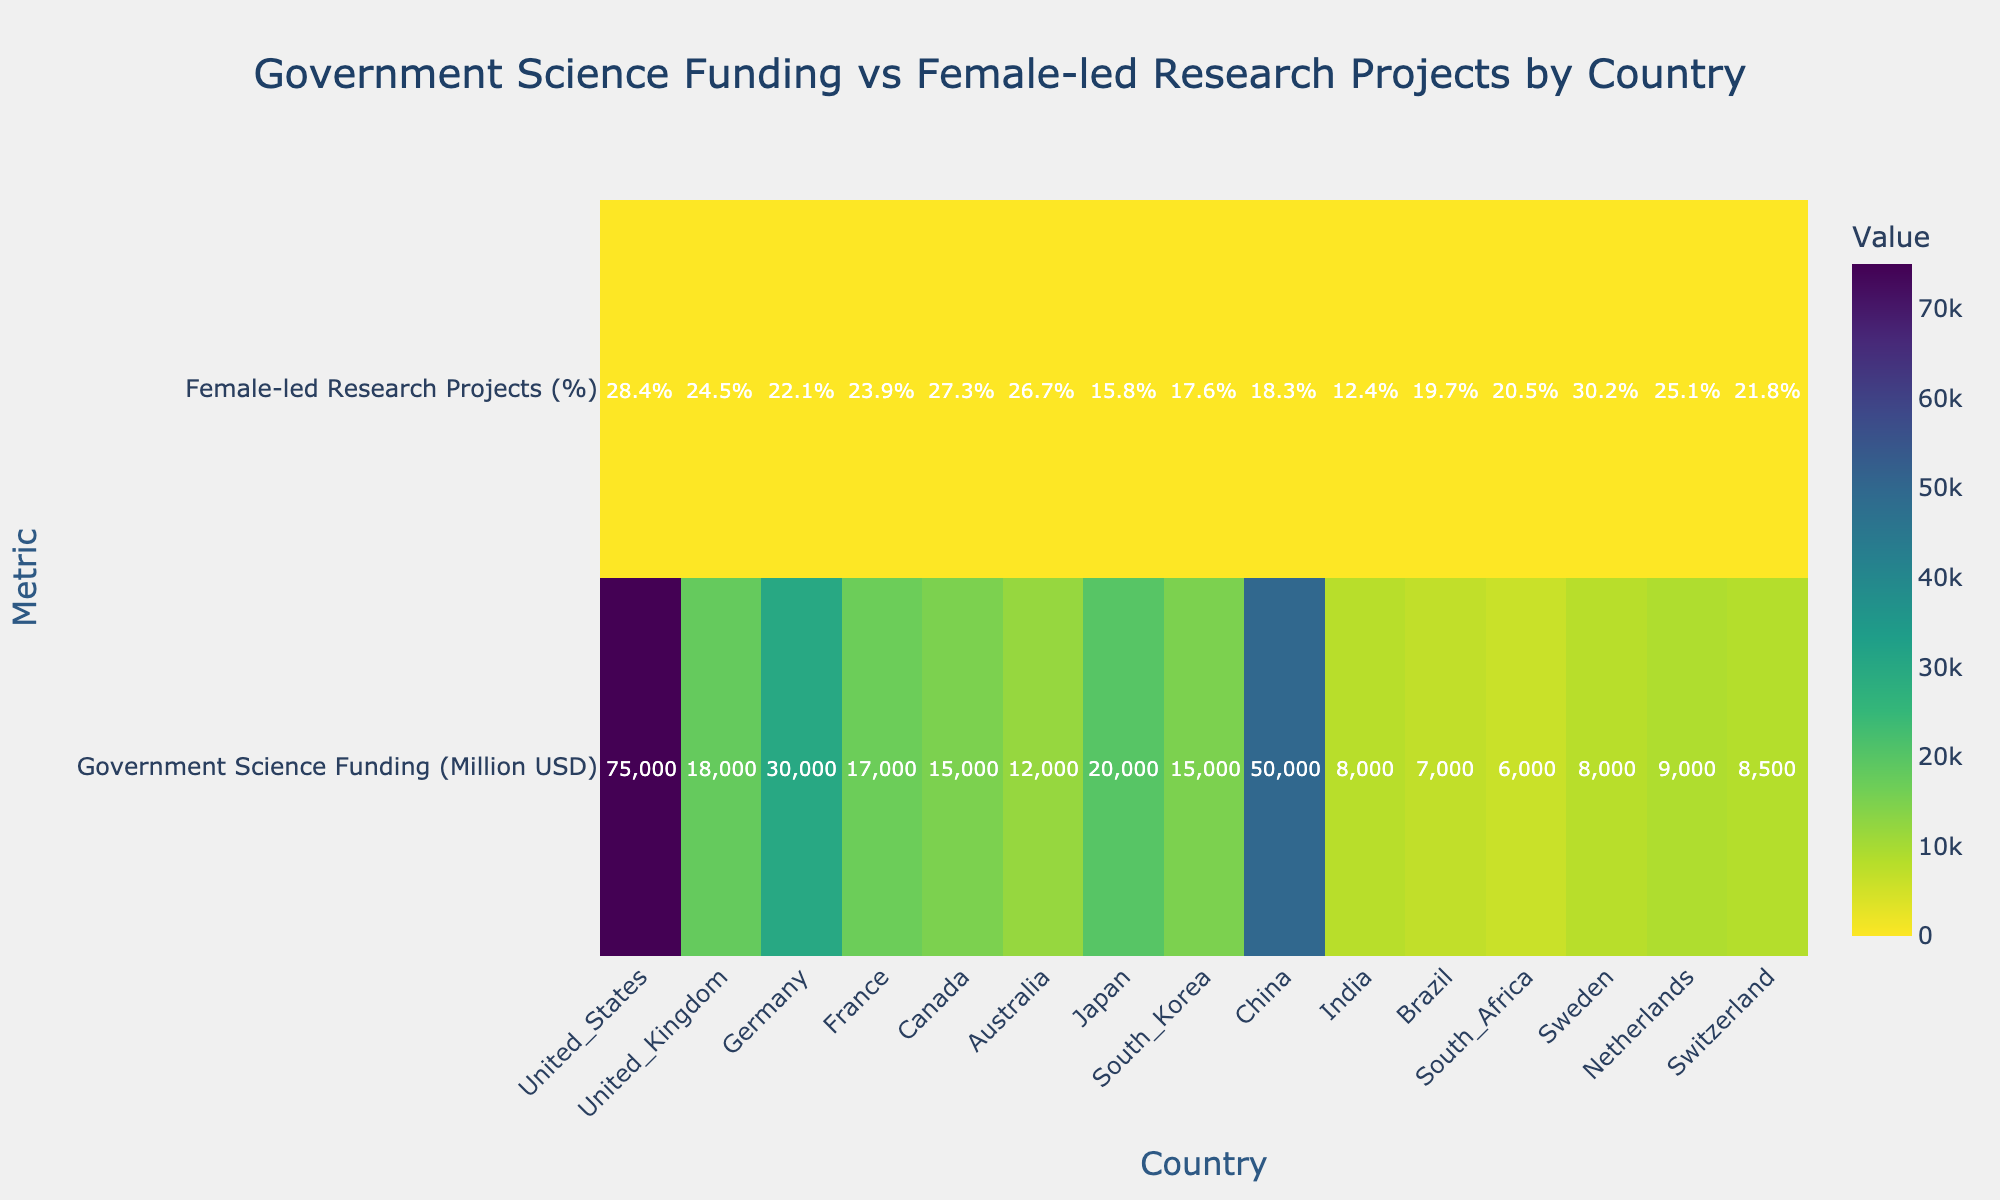What's the country with the highest percentage of female-led research projects? To find the country with the highest percentage of female-led research projects, look at the second row of the heatmap ('Female-led Research Projects (%)') and identify the country with the highest value. Sweden has the highest percentage at 30.2%.
Answer: Sweden What's the total amount of government science funding across all countries? Sum the values in the 'Government Science Funding (Million USD)' row: 75000 + 18000 + 30000 + 17000 + 15000 + 12000 + 20000 + 15000 + 50000 + 8000 + 7000 + 6000 + 8000 + 9000 + 8500 = 338500 million USD.
Answer: 338500 million USD Which country has the lowest percentage of female-led research projects? To find the country with the lowest percentage, look at the 'Female-led Research Projects (%)' row and identify the country with the lowest value. India has the lowest percentage at 12.4%.
Answer: India What is the difference in government science funding between the United States and China? Look at the 'Government Science Funding (Million USD)' row and subtract the value for China from the value for the United States: 75000 - 50000 = 25000 million USD.
Answer: 25000 million USD Which countries have more than 25% of their research projects led by females? Look at the 'Female-led Research Projects (%)' row and identify countries with values greater than 25%. The countries are United States (28.4%), Canada (27.3%), Australia (26.7%), and Sweden (30.2%).
Answer: United States, Canada, Australia, Sweden What's the average percentage of female-led research projects for all countries? Sum all percentages from the 'Female-led Research Projects (%)' row and divide by the number of countries: (28.4 + 24.5 + 22.1 + 23.9 + 27.3 + 26.7 + 15.8 + 17.6 + 18.3 + 12.4 + 19.7 + 20.5 + 30.2 + 25.1 + 21.8) / 15 = 22.8%.
Answer: 22.8% How does Japan compare to South Korea in terms of government science funding? Compare the values from the 'Government Science Funding (Million USD)' row for Japan (20000) and South Korea (15000). Japan has 5000 million USD more funding than South Korea.
Answer: Japan has 5000 million USD more funding Which country has the largest disparity between government science funding and the percentage of female-led research projects? Calculate the disparity for each country by taking the absolute difference between the two values in their respective rows. The United States has the largest funding (75000) and female percentage (28.4%), resulting in a larger disparity compared to other countries. However, for disparity percentage, contrast absolute numbers (e.g., Government funding) and percentage points (female-led projects), the largest relative difference could be more insightful: China has a relatively high government funding (50000) but lower female-led projects (18.3%). Specifically calculating each isn't feasible without the graph directly here, but these observations guide likely high disparities.
Answer: Likely China or USA Are there any countries where both government science funding and female-led research projects percentage are below the average values for all countries? Calculate the average government science funding (338500 / 15 = 22567 million USD) and the average female-led research projects percentage (22.8%). Identify countries below both averages: France (17000, 23.9%); India is interesting but above on one (8000 < 22567, 12.4% < 22.8%). If follow exact averages values, appropriately checking visual disparities might be better for accurate answer without graph direct view.
Answer: Not definitively within question strict according to visual prefer total data, or further check with specific graph alignment 